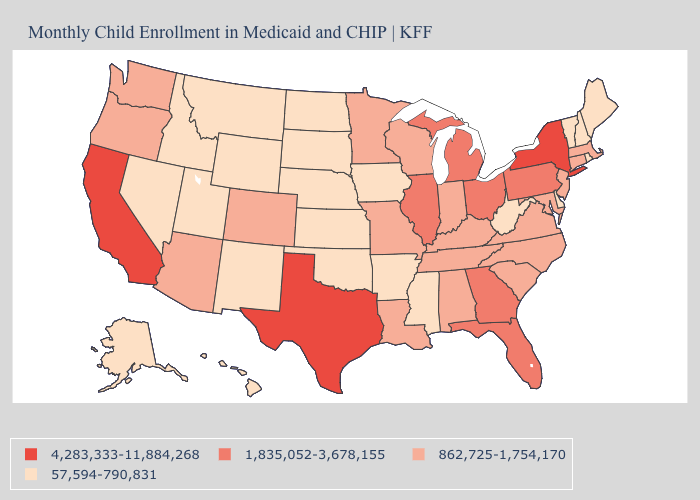What is the lowest value in states that border Illinois?
Answer briefly. 57,594-790,831. Does California have the lowest value in the USA?
Concise answer only. No. Which states hav the highest value in the West?
Keep it brief. California. Does California have the highest value in the West?
Give a very brief answer. Yes. Does Alaska have the lowest value in the West?
Be succinct. Yes. Does West Virginia have the same value as New Mexico?
Quick response, please. Yes. What is the value of Wyoming?
Write a very short answer. 57,594-790,831. Name the states that have a value in the range 1,835,052-3,678,155?
Write a very short answer. Florida, Georgia, Illinois, Michigan, Ohio, Pennsylvania. Does Oregon have a higher value than Texas?
Answer briefly. No. What is the highest value in the USA?
Keep it brief. 4,283,333-11,884,268. Among the states that border Nevada , does Idaho have the highest value?
Give a very brief answer. No. Does the map have missing data?
Concise answer only. No. What is the value of Montana?
Write a very short answer. 57,594-790,831. What is the lowest value in the USA?
Short answer required. 57,594-790,831. What is the lowest value in states that border North Carolina?
Be succinct. 862,725-1,754,170. 